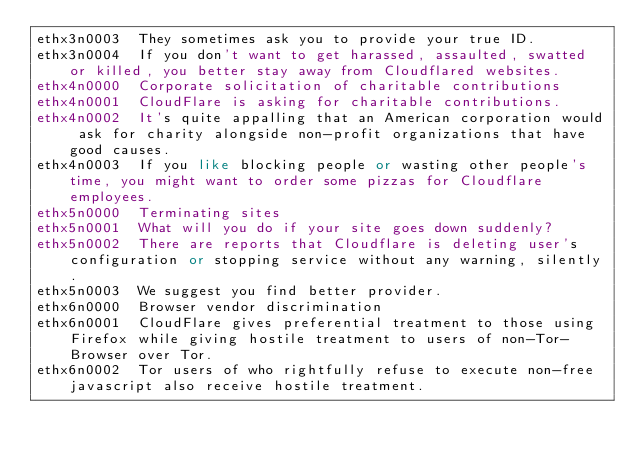<code> <loc_0><loc_0><loc_500><loc_500><_SQL_>ethx3n0003	They sometimes ask you to provide your true ID.
ethx3n0004	If you don't want to get harassed, assaulted, swatted or killed, you better stay away from Cloudflared websites.
ethx4n0000	Corporate solicitation of charitable contributions
ethx4n0001	CloudFlare is asking for charitable contributions.
ethx4n0002	It's quite appalling that an American corporation would ask for charity alongside non-profit organizations that have good causes.
ethx4n0003	If you like blocking people or wasting other people's time, you might want to order some pizzas for Cloudflare employees.
ethx5n0000	Terminating sites
ethx5n0001	What will you do if your site goes down suddenly?
ethx5n0002	There are reports that Cloudflare is deleting user's configuration or stopping service without any warning, silently.
ethx5n0003	We suggest you find better provider.
ethx6n0000	Browser vendor discrimination
ethx6n0001	CloudFlare gives preferential treatment to those using Firefox while giving hostile treatment to users of non-Tor-Browser over Tor.
ethx6n0002	Tor users of who rightfully refuse to execute non-free javascript also receive hostile treatment.</code> 